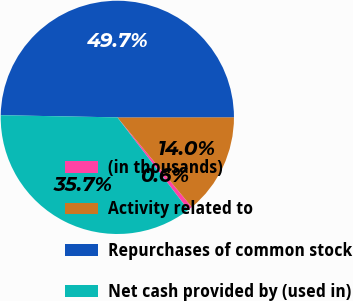<chart> <loc_0><loc_0><loc_500><loc_500><pie_chart><fcel>(in thousands)<fcel>Activity related to<fcel>Repurchases of common stock<fcel>Net cash provided by (used in)<nl><fcel>0.62%<fcel>13.99%<fcel>49.69%<fcel>35.7%<nl></chart> 